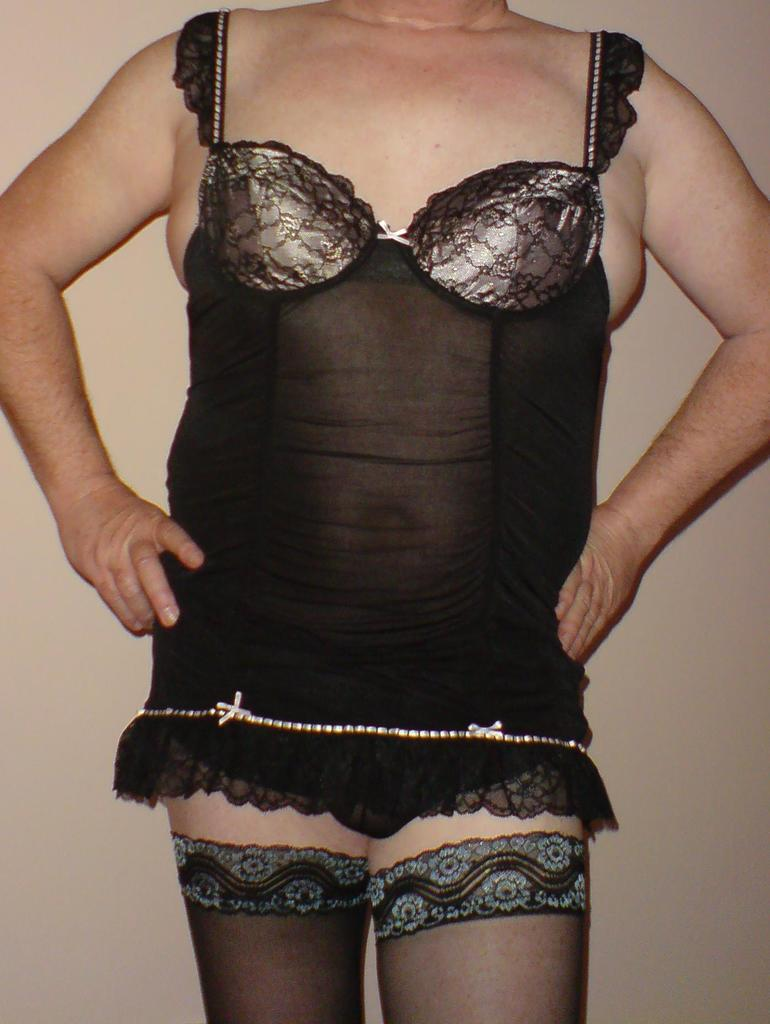Who or what is present in the image? There is a person in the image. What is the person wearing? The person is wearing a black dress. What can be seen in the background of the image? There is a well in the background of the image. What type of rice is being prepared by the maid in the image? There is no maid or rice present in the image. What process is the person in the image undergoing? The image does not provide information about any process the person might be undergoing. 